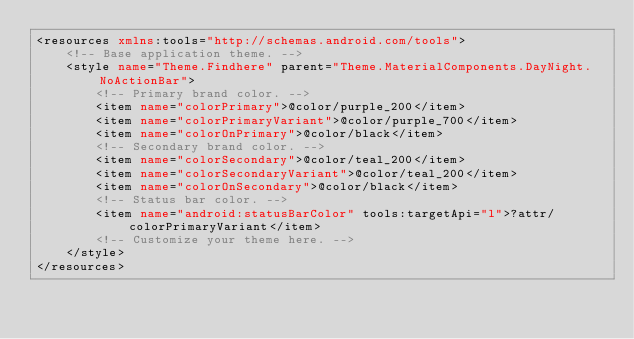<code> <loc_0><loc_0><loc_500><loc_500><_XML_><resources xmlns:tools="http://schemas.android.com/tools">
    <!-- Base application theme. -->
    <style name="Theme.Findhere" parent="Theme.MaterialComponents.DayNight.NoActionBar">
        <!-- Primary brand color. -->
        <item name="colorPrimary">@color/purple_200</item>
        <item name="colorPrimaryVariant">@color/purple_700</item>
        <item name="colorOnPrimary">@color/black</item>
        <!-- Secondary brand color. -->
        <item name="colorSecondary">@color/teal_200</item>
        <item name="colorSecondaryVariant">@color/teal_200</item>
        <item name="colorOnSecondary">@color/black</item>
        <!-- Status bar color. -->
        <item name="android:statusBarColor" tools:targetApi="l">?attr/colorPrimaryVariant</item>
        <!-- Customize your theme here. -->
    </style>
</resources></code> 